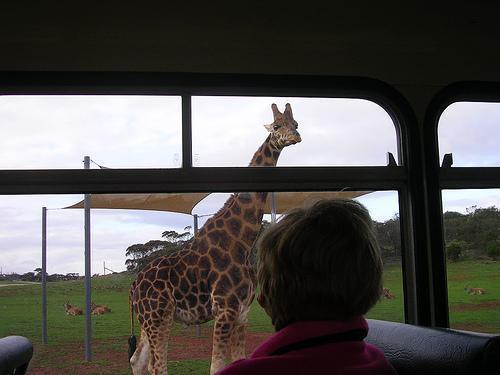How many people are in the picture?
Give a very brief answer. 1. 